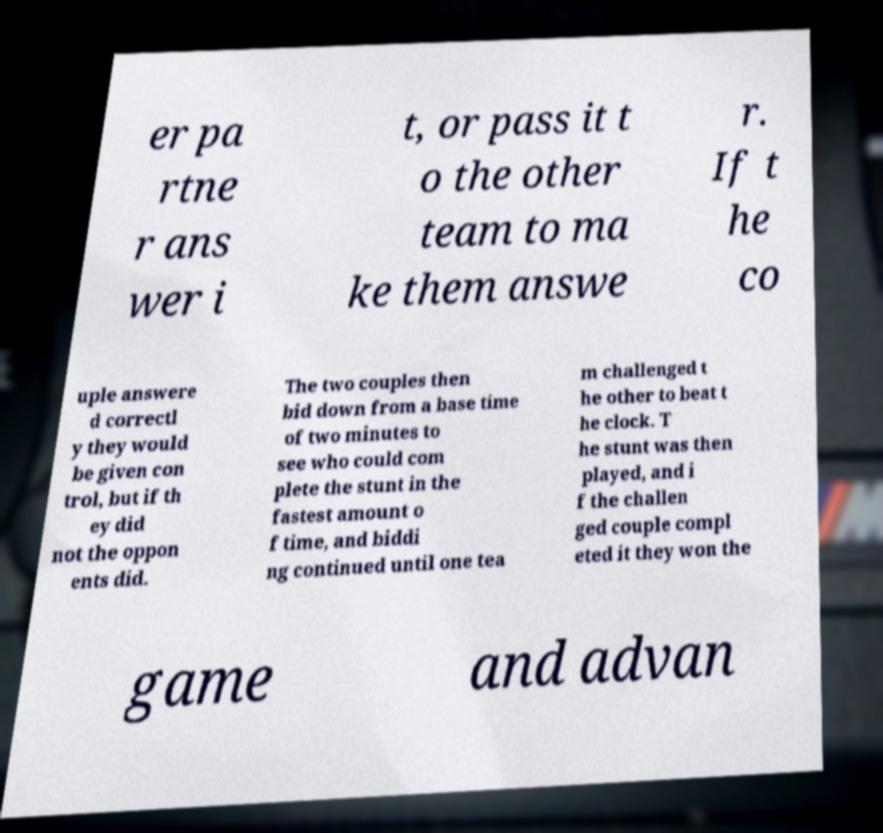I need the written content from this picture converted into text. Can you do that? er pa rtne r ans wer i t, or pass it t o the other team to ma ke them answe r. If t he co uple answere d correctl y they would be given con trol, but if th ey did not the oppon ents did. The two couples then bid down from a base time of two minutes to see who could com plete the stunt in the fastest amount o f time, and biddi ng continued until one tea m challenged t he other to beat t he clock. T he stunt was then played, and i f the challen ged couple compl eted it they won the game and advan 